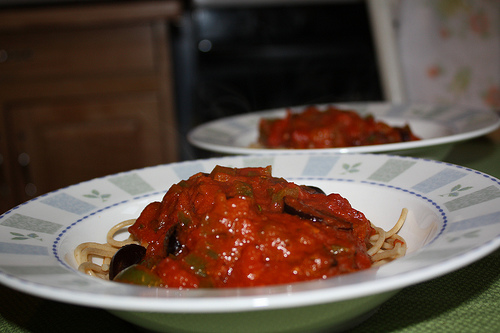<image>
Is there a plate under the food? Yes. The plate is positioned underneath the food, with the food above it in the vertical space. Is the food under the plate? No. The food is not positioned under the plate. The vertical relationship between these objects is different. 